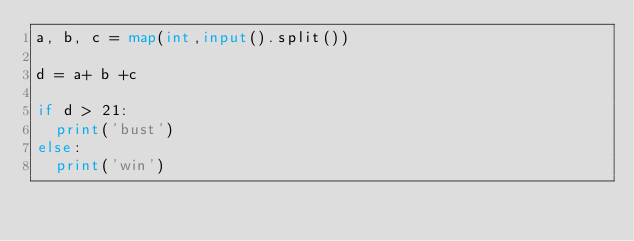<code> <loc_0><loc_0><loc_500><loc_500><_Python_>a, b, c = map(int,input().split())

d = a+ b +c

if d > 21:
  print('bust')
else:
  print('win')</code> 